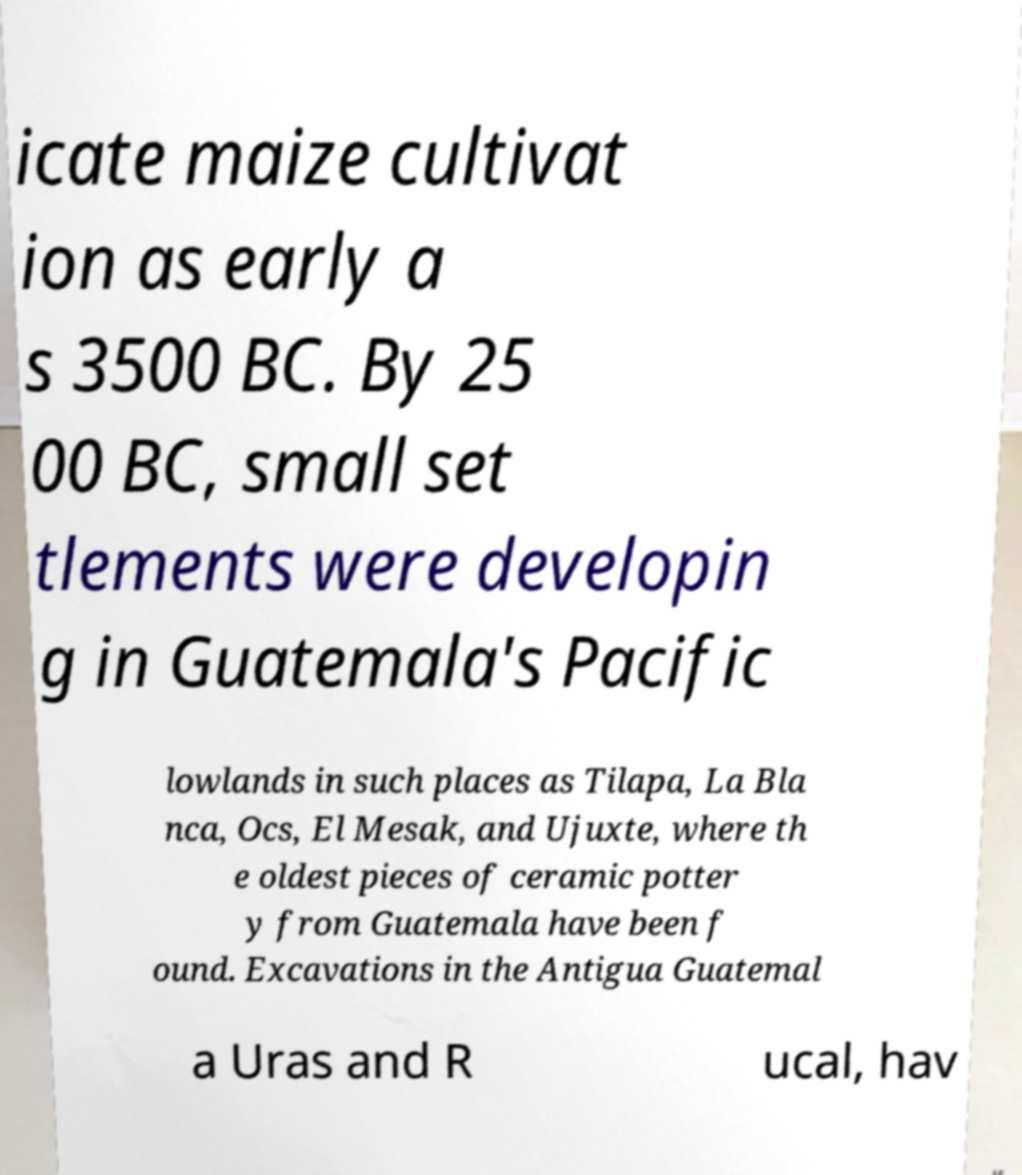There's text embedded in this image that I need extracted. Can you transcribe it verbatim? icate maize cultivat ion as early a s 3500 BC. By 25 00 BC, small set tlements were developin g in Guatemala's Pacific lowlands in such places as Tilapa, La Bla nca, Ocs, El Mesak, and Ujuxte, where th e oldest pieces of ceramic potter y from Guatemala have been f ound. Excavations in the Antigua Guatemal a Uras and R ucal, hav 